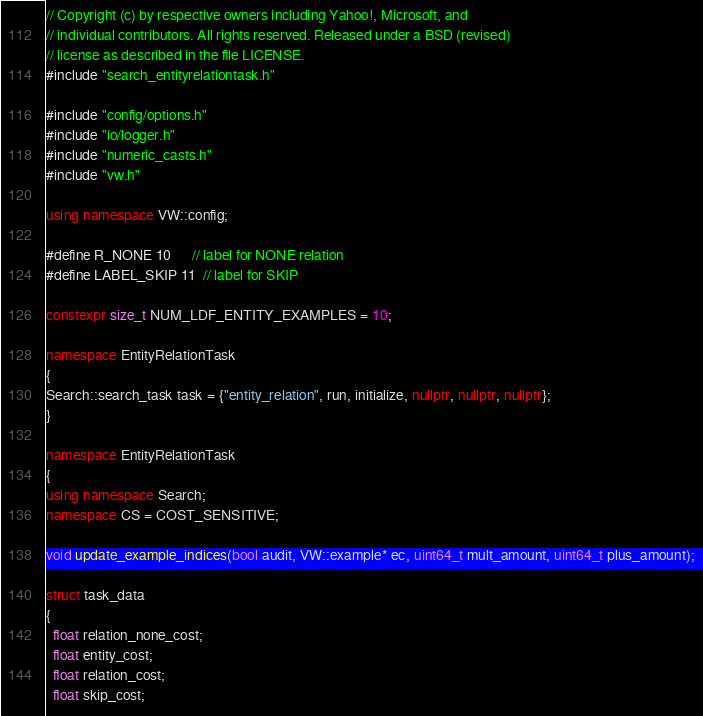<code> <loc_0><loc_0><loc_500><loc_500><_C++_>// Copyright (c) by respective owners including Yahoo!, Microsoft, and
// individual contributors. All rights reserved. Released under a BSD (revised)
// license as described in the file LICENSE.
#include "search_entityrelationtask.h"

#include "config/options.h"
#include "io/logger.h"
#include "numeric_casts.h"
#include "vw.h"

using namespace VW::config;

#define R_NONE 10      // label for NONE relation
#define LABEL_SKIP 11  // label for SKIP

constexpr size_t NUM_LDF_ENTITY_EXAMPLES = 10;

namespace EntityRelationTask
{
Search::search_task task = {"entity_relation", run, initialize, nullptr, nullptr, nullptr};
}

namespace EntityRelationTask
{
using namespace Search;
namespace CS = COST_SENSITIVE;

void update_example_indices(bool audit, VW::example* ec, uint64_t mult_amount, uint64_t plus_amount);

struct task_data
{
  float relation_none_cost;
  float entity_cost;
  float relation_cost;
  float skip_cost;</code> 